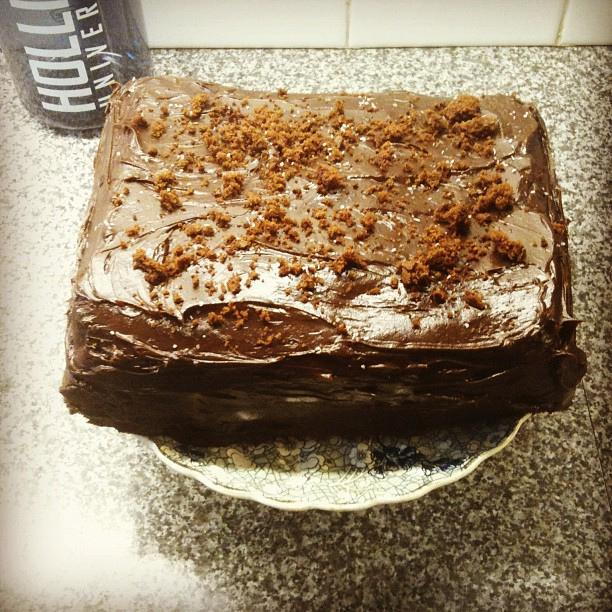What would this food item be ideal for? birthday 